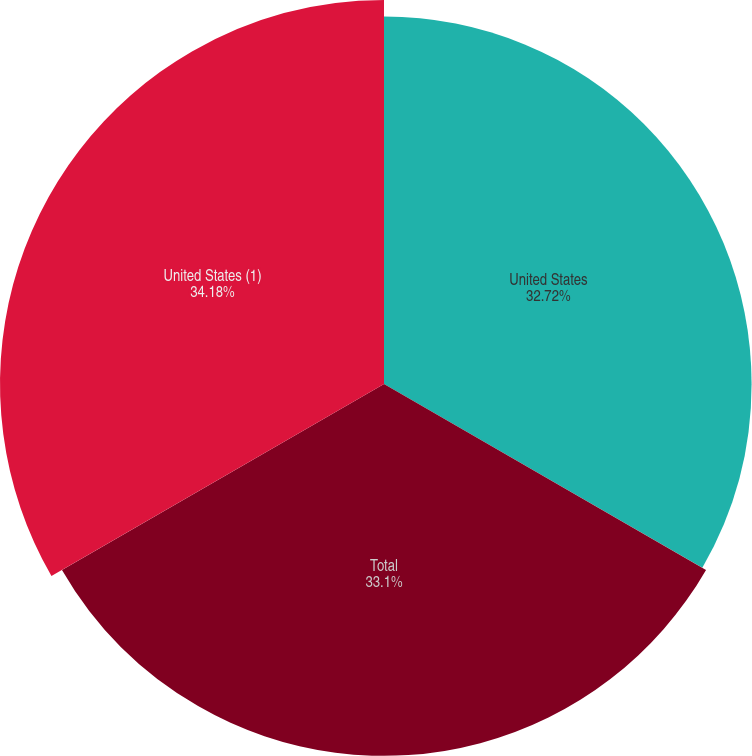Convert chart to OTSL. <chart><loc_0><loc_0><loc_500><loc_500><pie_chart><fcel>United States<fcel>Total<fcel>United States (1)<nl><fcel>32.72%<fcel>33.1%<fcel>34.18%<nl></chart> 